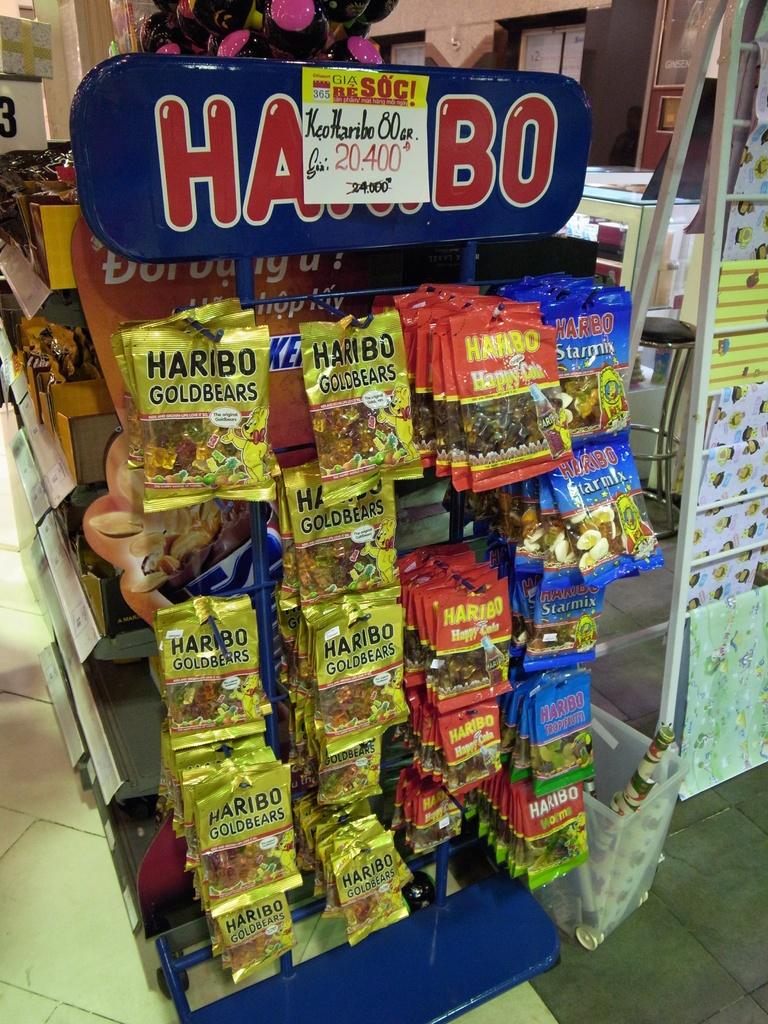What brand of gummi bears are carried here?
Offer a terse response. Haribo. What kind of candy in the red bag? (2 words)?
Give a very brief answer. Happy cola. 